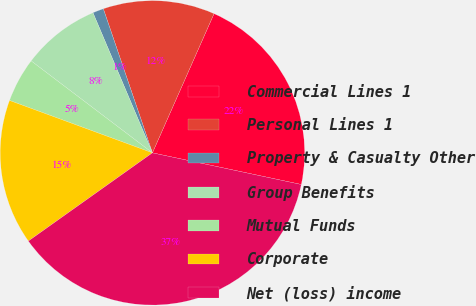Convert chart to OTSL. <chart><loc_0><loc_0><loc_500><loc_500><pie_chart><fcel>Commercial Lines 1<fcel>Personal Lines 1<fcel>Property & Casualty Other<fcel>Group Benefits<fcel>Mutual Funds<fcel>Corporate<fcel>Net (loss) income<nl><fcel>21.7%<fcel>11.86%<fcel>1.16%<fcel>8.29%<fcel>4.73%<fcel>15.43%<fcel>36.83%<nl></chart> 